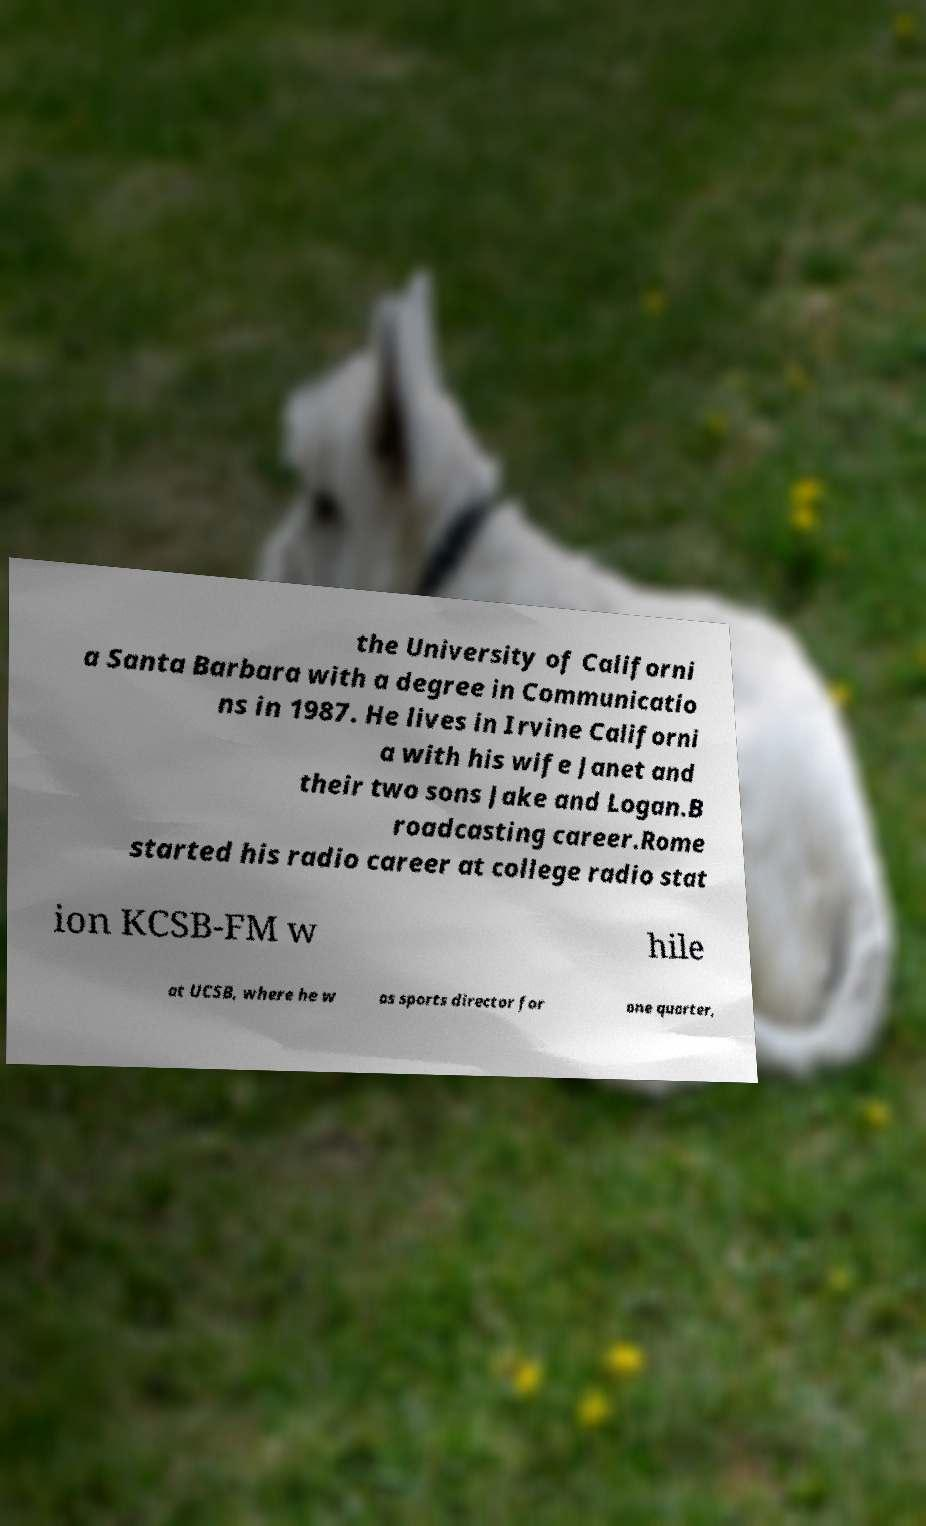Could you extract and type out the text from this image? the University of Californi a Santa Barbara with a degree in Communicatio ns in 1987. He lives in Irvine Californi a with his wife Janet and their two sons Jake and Logan.B roadcasting career.Rome started his radio career at college radio stat ion KCSB-FM w hile at UCSB, where he w as sports director for one quarter, 